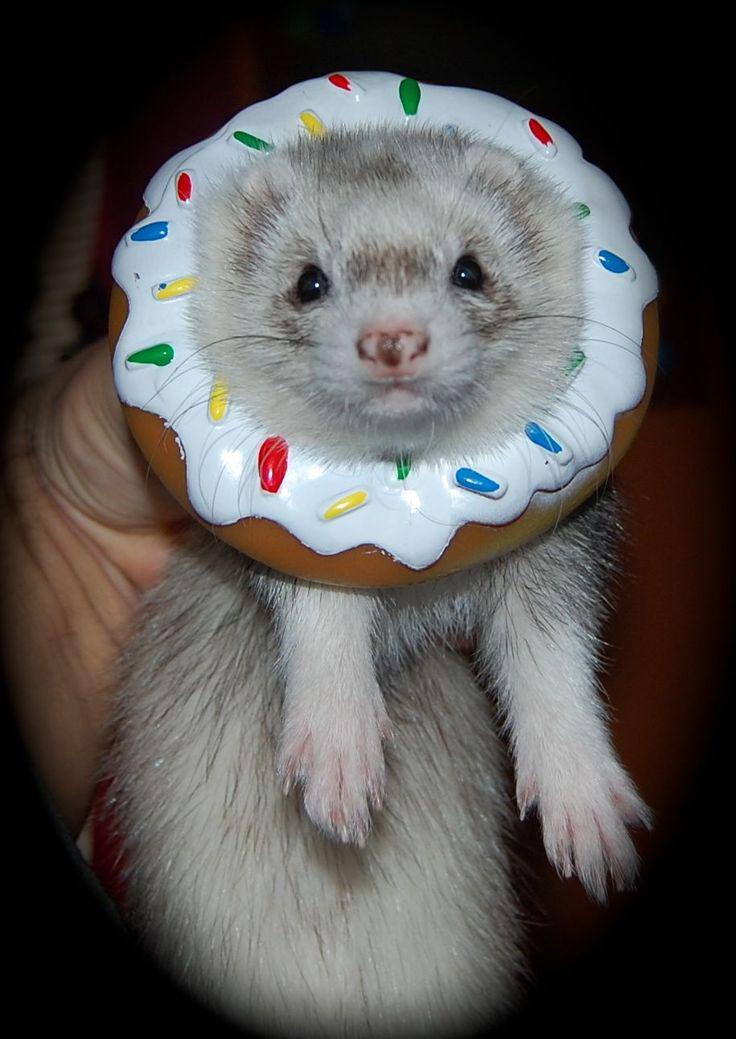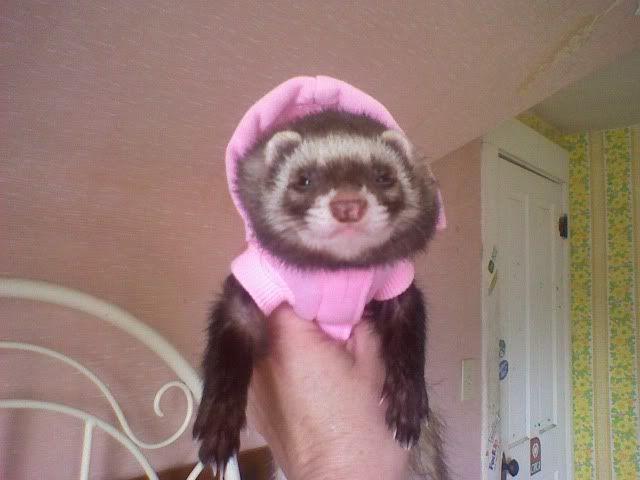The first image is the image on the left, the second image is the image on the right. For the images displayed, is the sentence "The left image contains one sleeping ferret." factually correct? Answer yes or no. No. The first image is the image on the left, the second image is the image on the right. Examine the images to the left and right. Is the description "At least one of the ferrets is wearing something on its head." accurate? Answer yes or no. Yes. 